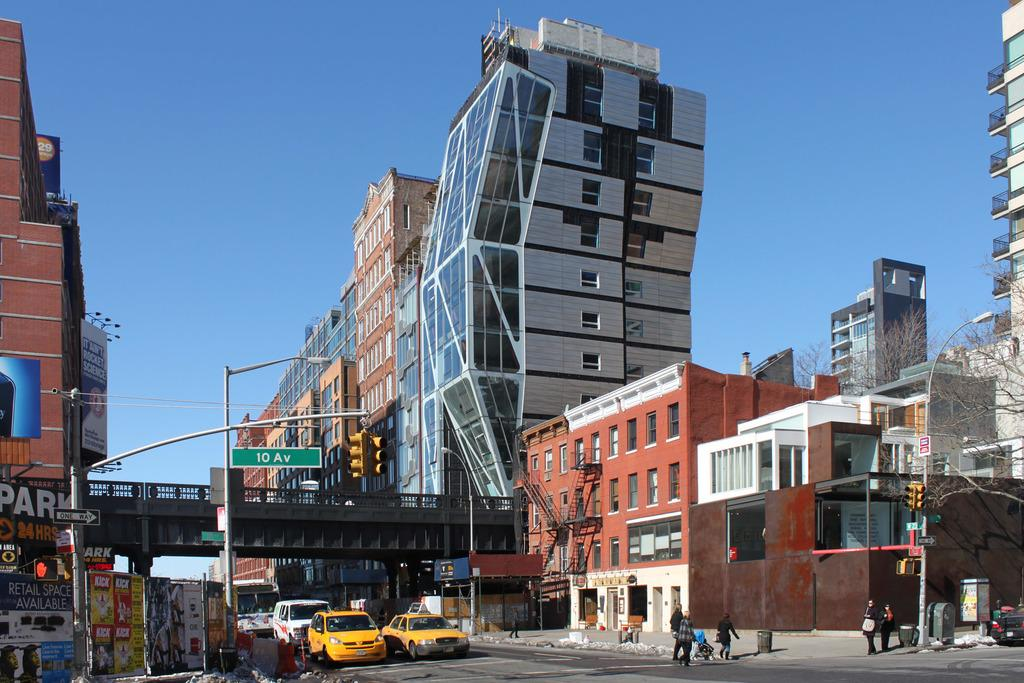<image>
Give a short and clear explanation of the subsequent image. Retail space is available on 10 Av according to the sign. 